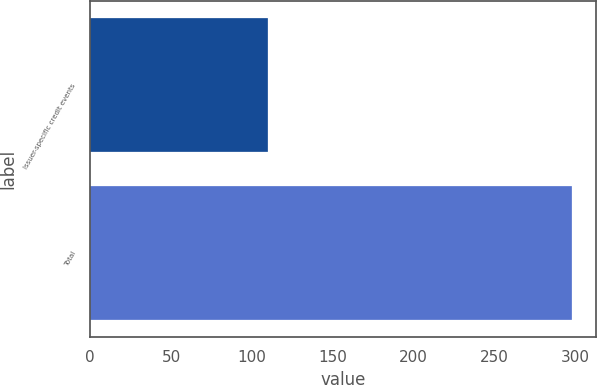Convert chart. <chart><loc_0><loc_0><loc_500><loc_500><bar_chart><fcel>Issuer-specific credit events<fcel>Total<nl><fcel>110<fcel>298<nl></chart> 